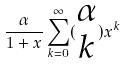<formula> <loc_0><loc_0><loc_500><loc_500>\frac { \alpha } { 1 + x } \sum _ { k = 0 } ^ { \infty } ( \begin{matrix} \alpha \\ k \end{matrix} ) x ^ { k }</formula> 